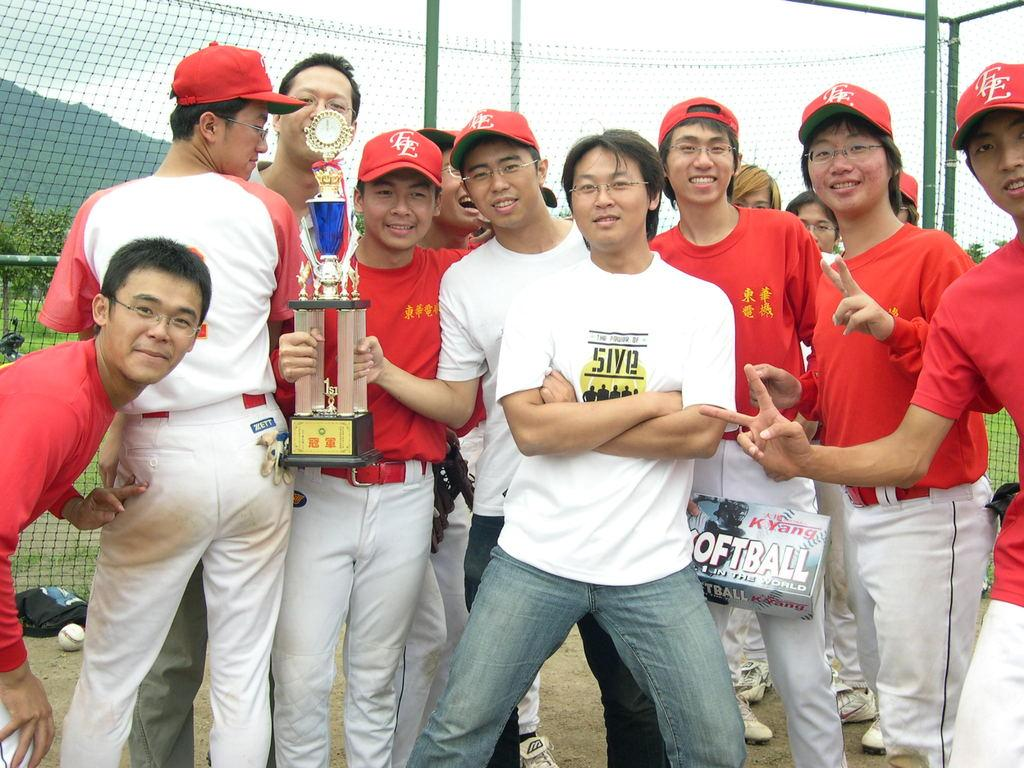<image>
Write a terse but informative summary of the picture. A man wearing a 5ive t-shirt poses with baseball players. 